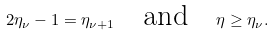Convert formula to latex. <formula><loc_0><loc_0><loc_500><loc_500>2 \eta _ { \nu } - 1 = \eta _ { \nu + 1 } \quad \text {and} \quad \eta \geq \eta _ { \nu } .</formula> 